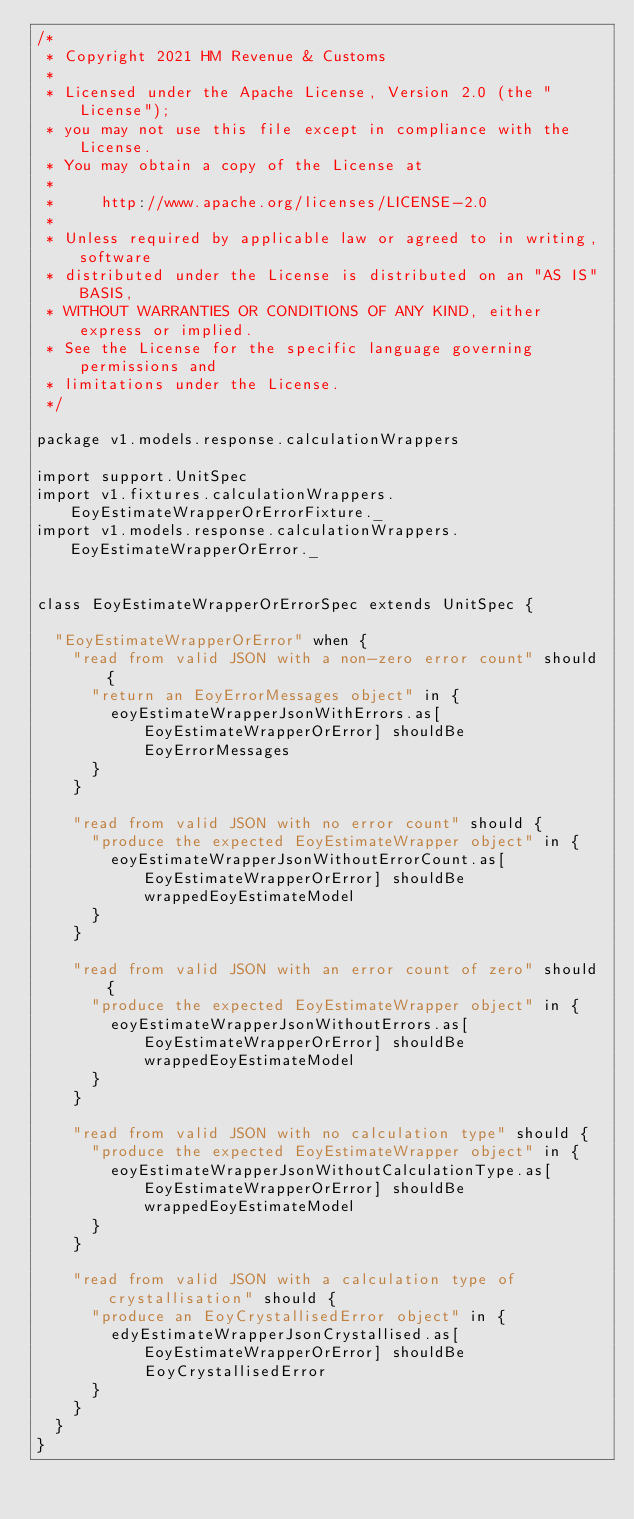Convert code to text. <code><loc_0><loc_0><loc_500><loc_500><_Scala_>/*
 * Copyright 2021 HM Revenue & Customs
 *
 * Licensed under the Apache License, Version 2.0 (the "License");
 * you may not use this file except in compliance with the License.
 * You may obtain a copy of the License at
 *
 *     http://www.apache.org/licenses/LICENSE-2.0
 *
 * Unless required by applicable law or agreed to in writing, software
 * distributed under the License is distributed on an "AS IS" BASIS,
 * WITHOUT WARRANTIES OR CONDITIONS OF ANY KIND, either express or implied.
 * See the License for the specific language governing permissions and
 * limitations under the License.
 */

package v1.models.response.calculationWrappers

import support.UnitSpec
import v1.fixtures.calculationWrappers.EoyEstimateWrapperOrErrorFixture._
import v1.models.response.calculationWrappers.EoyEstimateWrapperOrError._


class EoyEstimateWrapperOrErrorSpec extends UnitSpec {

  "EoyEstimateWrapperOrError" when {
    "read from valid JSON with a non-zero error count" should {
      "return an EoyErrorMessages object" in {
        eoyEstimateWrapperJsonWithErrors.as[EoyEstimateWrapperOrError] shouldBe EoyErrorMessages
      }
    }

    "read from valid JSON with no error count" should {
      "produce the expected EoyEstimateWrapper object" in {
        eoyEstimateWrapperJsonWithoutErrorCount.as[EoyEstimateWrapperOrError] shouldBe wrappedEoyEstimateModel
      }
    }

    "read from valid JSON with an error count of zero" should {
      "produce the expected EoyEstimateWrapper object" in {
        eoyEstimateWrapperJsonWithoutErrors.as[EoyEstimateWrapperOrError] shouldBe wrappedEoyEstimateModel
      }
    }

    "read from valid JSON with no calculation type" should {
      "produce the expected EoyEstimateWrapper object" in {
        eoyEstimateWrapperJsonWithoutCalculationType.as[EoyEstimateWrapperOrError] shouldBe wrappedEoyEstimateModel
      }
    }

    "read from valid JSON with a calculation type of crystallisation" should {
      "produce an EoyCrystallisedError object" in {
        edyEstimateWrapperJsonCrystallised.as[EoyEstimateWrapperOrError] shouldBe EoyCrystallisedError
      }
    }
  }
}
</code> 